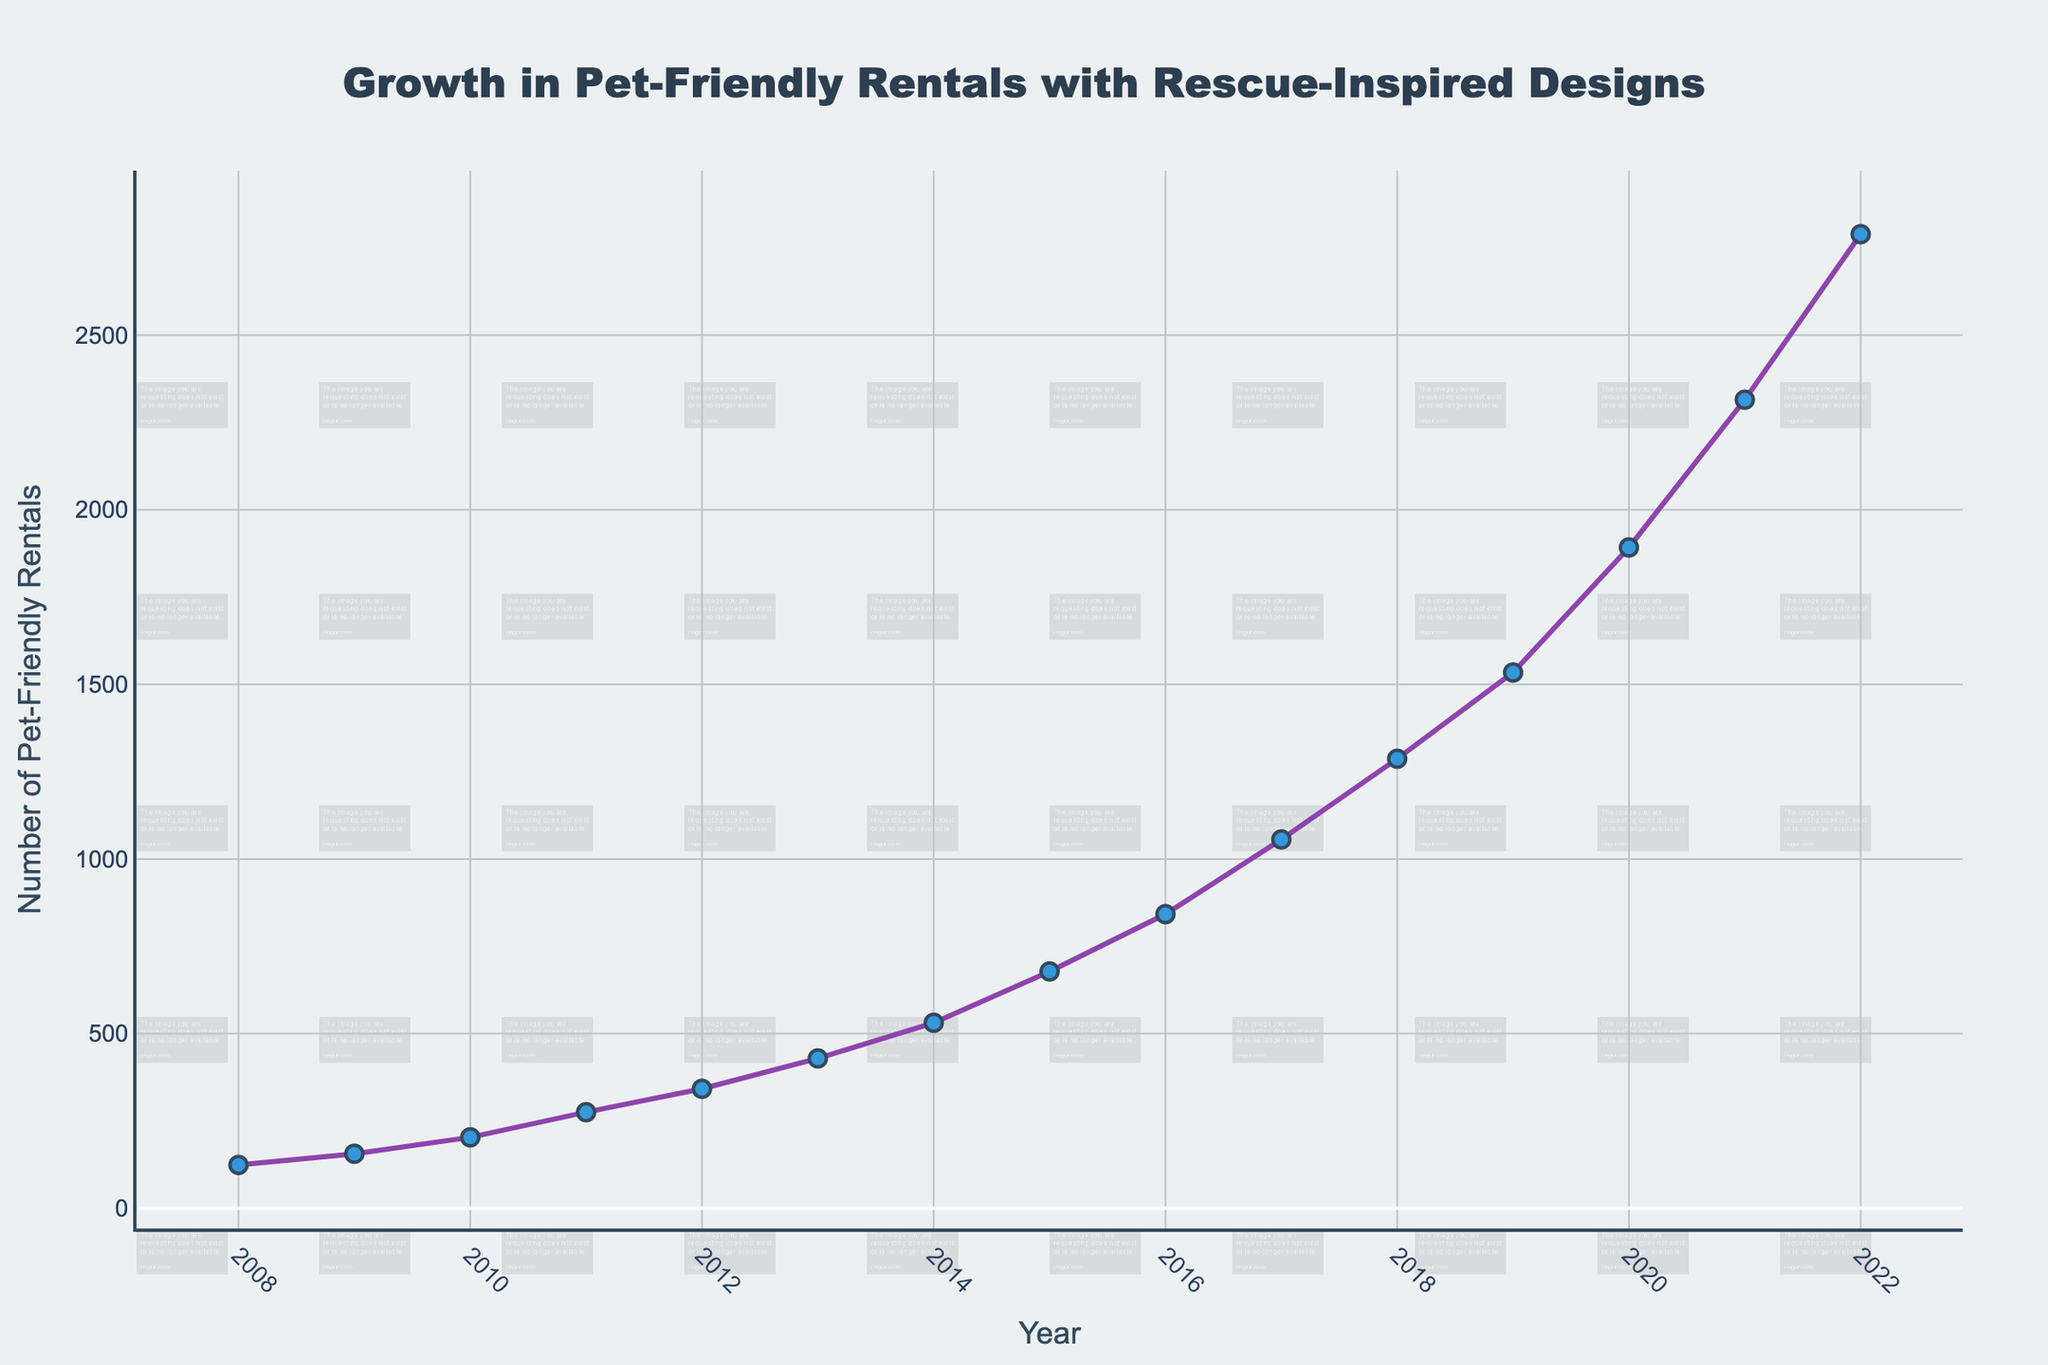What is the number of pet-friendly rentals with rescue-inspired designs in 2011? By looking at the data for the year 2011 on the line chart, we can see the corresponding value.
Answer: 275 How many pet-friendly rentals with rescue-inspired designs were there in 2008 and 2022 combined? The number of rentals in 2008 is 124 and in 2022 is 2789. Summing these values gives 124 + 2789.
Answer: 2913 Between which two consecutive years did the number of pet-friendly rentals with rescue-inspired designs grow the most? We need to look at the differences between each pair of consecutive years and find the maximum. The largest year-on-year increase can be observed from 2019 to 2020 (1534 -> 1892, an increase of 358).
Answer: 2019-2020 What is the overall trend in the number of pet-friendly rentals with rescue-inspired designs from 2008 to 2022? By observing the trend shown by the line on the chart, we can see a steady and significant increase over the years.
Answer: Steadily increasing In which year did the number of pet-friendly rentals with rescue-inspired designs exceed 1000 for the first time? We need to identify the year when the value crosses the 1000 mark. This happens first in 2017.
Answer: 2017 What is the average number of pet-friendly rentals with rescue-inspired designs over the 15 years? Sum all the given yearly values and divide by the number of years (15). (124 + 156 + 203 + 275 + 342 + 429 + 531 + 678 + 842 + 1056 + 1287 + 1534 + 1892 + 2315 + 2789) / 15 gives the average.
Answer: 1017.87 By how much did the number of pet-friendly rentals with rescue-inspired designs increase from 2008 to 2022? Subtract the number of rentals in 2008 from the number in 2022 (2789 - 124).
Answer: 2665 